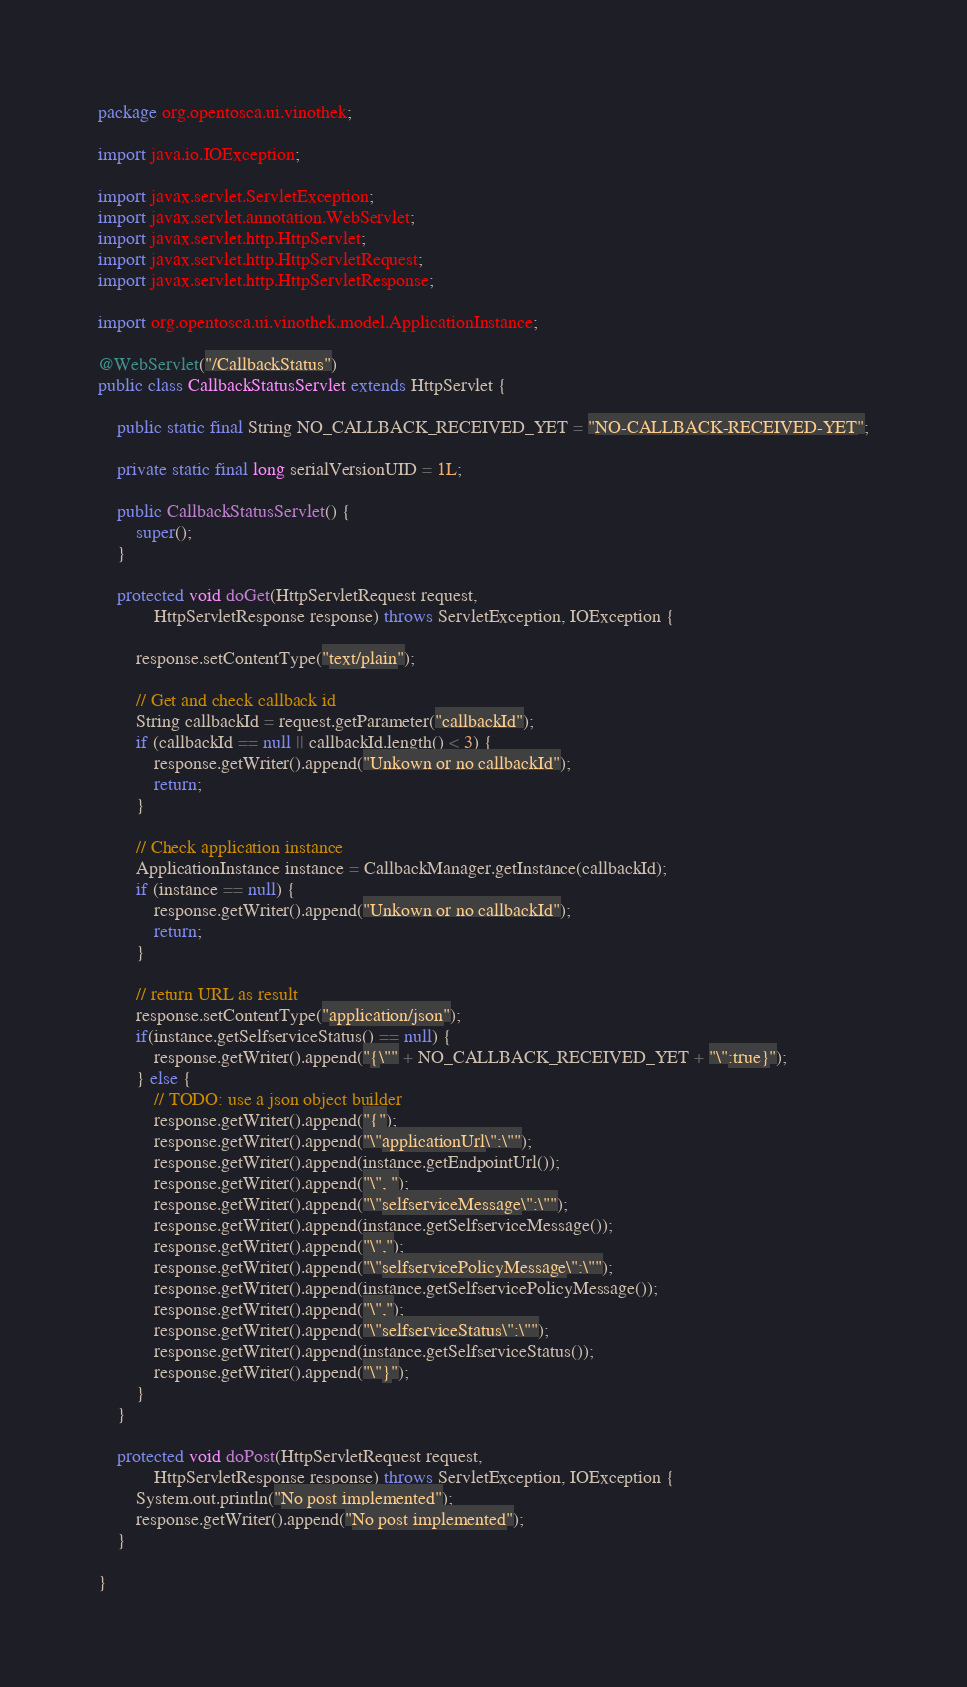<code> <loc_0><loc_0><loc_500><loc_500><_Java_>package org.opentosca.ui.vinothek;

import java.io.IOException;

import javax.servlet.ServletException;
import javax.servlet.annotation.WebServlet;
import javax.servlet.http.HttpServlet;
import javax.servlet.http.HttpServletRequest;
import javax.servlet.http.HttpServletResponse;

import org.opentosca.ui.vinothek.model.ApplicationInstance;

@WebServlet("/CallbackStatus")
public class CallbackStatusServlet extends HttpServlet {
	
	public static final String NO_CALLBACK_RECEIVED_YET = "NO-CALLBACK-RECEIVED-YET";
	
	private static final long serialVersionUID = 1L;

	public CallbackStatusServlet() {
		super();
	}

	protected void doGet(HttpServletRequest request,
			HttpServletResponse response) throws ServletException, IOException {
		
		response.setContentType("text/plain");

		// Get and check callback id
		String callbackId = request.getParameter("callbackId");
		if (callbackId == null || callbackId.length() < 3) {
			response.getWriter().append("Unkown or no callbackId");
			return;
		}

		// Check application instance
		ApplicationInstance instance = CallbackManager.getInstance(callbackId);
		if (instance == null) {
			response.getWriter().append("Unkown or no callbackId");
			return;
		}

		// return URL as result
		response.setContentType("application/json");
		if(instance.getSelfserviceStatus() == null) {
			response.getWriter().append("{\"" + NO_CALLBACK_RECEIVED_YET + "\":true}");
		} else {
			// TODO: use a json object builder
			response.getWriter().append("{");
			response.getWriter().append("\"applicationUrl\":\"");
			response.getWriter().append(instance.getEndpointUrl());
			response.getWriter().append("\", ");
			response.getWriter().append("\"selfserviceMessage\":\"");
			response.getWriter().append(instance.getSelfserviceMessage());
			response.getWriter().append("\",");
			response.getWriter().append("\"selfservicePolicyMessage\":\"");
			response.getWriter().append(instance.getSelfservicePolicyMessage());
			response.getWriter().append("\",");
			response.getWriter().append("\"selfserviceStatus\":\"");
			response.getWriter().append(instance.getSelfserviceStatus());
			response.getWriter().append("\"}");
		}
	}

	protected void doPost(HttpServletRequest request,
			HttpServletResponse response) throws ServletException, IOException {
		System.out.println("No post implemented");
		response.getWriter().append("No post implemented");
	}

}
</code> 